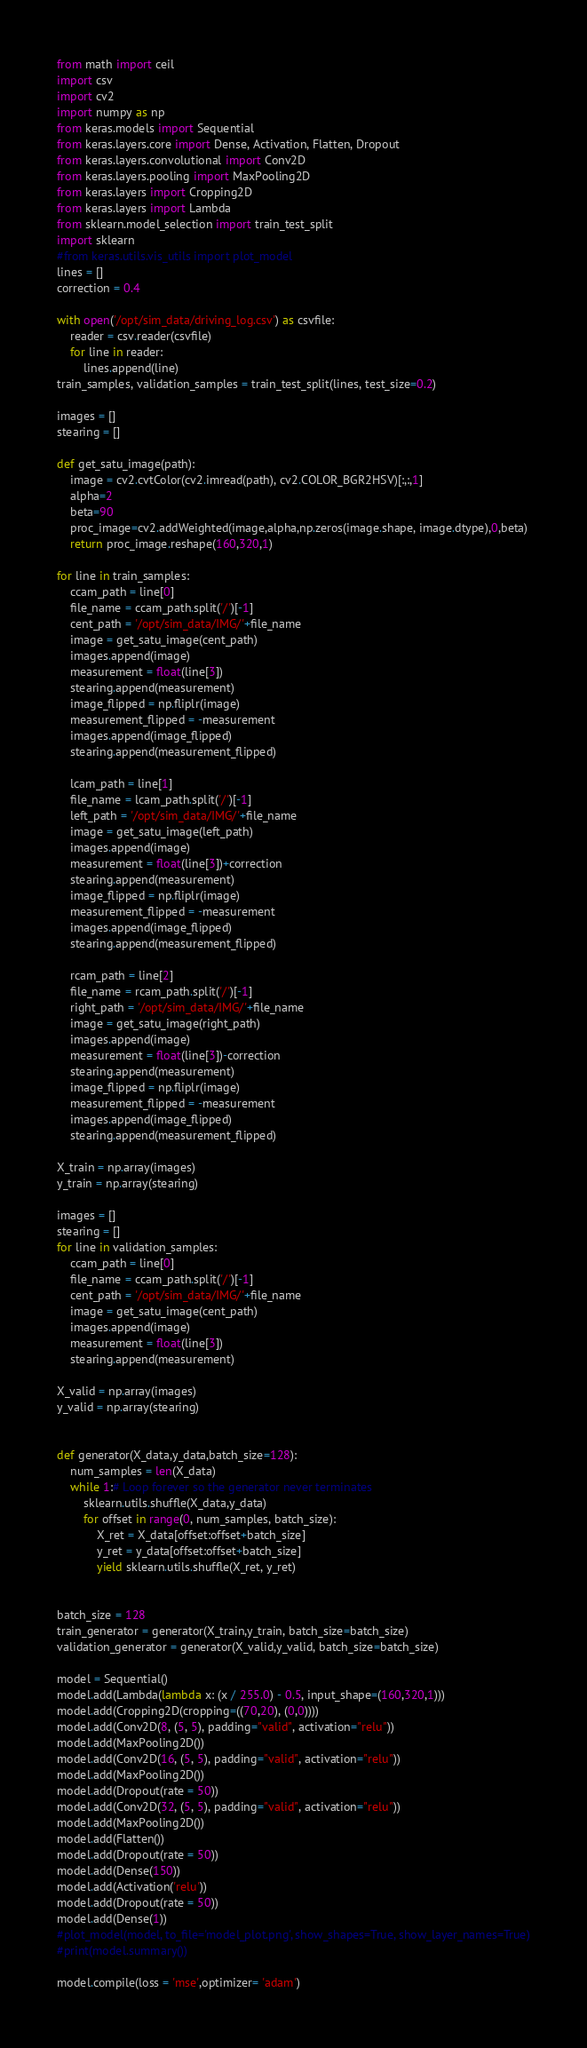Convert code to text. <code><loc_0><loc_0><loc_500><loc_500><_Python_>from math import ceil
import csv 
import cv2
import numpy as np
from keras.models import Sequential
from keras.layers.core import Dense, Activation, Flatten, Dropout
from keras.layers.convolutional import Conv2D
from keras.layers.pooling import MaxPooling2D
from keras.layers import Cropping2D
from keras.layers import Lambda
from sklearn.model_selection import train_test_split
import sklearn
#from keras.utils.vis_utils import plot_model
lines = []
correction = 0.4

with open('/opt/sim_data/driving_log.csv') as csvfile:
    reader = csv.reader(csvfile)
    for line in reader:
        lines.append(line)
train_samples, validation_samples = train_test_split(lines, test_size=0.2)

images = []
stearing = []

def get_satu_image(path):
    image = cv2.cvtColor(cv2.imread(path), cv2.COLOR_BGR2HSV)[:,:,1]
    alpha=2
    beta=90
    proc_image=cv2.addWeighted(image,alpha,np.zeros(image.shape, image.dtype),0,beta)
    return proc_image.reshape(160,320,1)
    
for line in train_samples:
    ccam_path = line[0]
    file_name = ccam_path.split('/')[-1]
    cent_path = '/opt/sim_data/IMG/'+file_name
    image = get_satu_image(cent_path)    
    images.append(image)
    measurement = float(line[3])
    stearing.append(measurement)
    image_flipped = np.fliplr(image)
    measurement_flipped = -measurement
    images.append(image_flipped)
    stearing.append(measurement_flipped)

    lcam_path = line[1]
    file_name = lcam_path.split('/')[-1]
    left_path = '/opt/sim_data/IMG/'+file_name
    image = get_satu_image(left_path)
    images.append(image)
    measurement = float(line[3])+correction
    stearing.append(measurement)
    image_flipped = np.fliplr(image)
    measurement_flipped = -measurement
    images.append(image_flipped)
    stearing.append(measurement_flipped)

    rcam_path = line[2]
    file_name = rcam_path.split('/')[-1]
    right_path = '/opt/sim_data/IMG/'+file_name
    image = get_satu_image(right_path)
    images.append(image)
    measurement = float(line[3])-correction
    stearing.append(measurement)
    image_flipped = np.fliplr(image)
    measurement_flipped = -measurement
    images.append(image_flipped)
    stearing.append(measurement_flipped)

X_train = np.array(images)
y_train = np.array(stearing)

images = []
stearing = []
for line in validation_samples:
    ccam_path = line[0]
    file_name = ccam_path.split('/')[-1]
    cent_path = '/opt/sim_data/IMG/'+file_name
    image = get_satu_image(cent_path)
    images.append(image)
    measurement = float(line[3])
    stearing.append(measurement)   

X_valid = np.array(images)
y_valid = np.array(stearing)


def generator(X_data,y_data,batch_size=128):
    num_samples = len(X_data)
    while 1:# Loop forever so the generator never terminates
        sklearn.utils.shuffle(X_data,y_data)
        for offset in range(0, num_samples, batch_size):
            X_ret = X_data[offset:offset+batch_size]
            y_ret = y_data[offset:offset+batch_size]
            yield sklearn.utils.shuffle(X_ret, y_ret)
            

batch_size = 128
train_generator = generator(X_train,y_train, batch_size=batch_size)
validation_generator = generator(X_valid,y_valid, batch_size=batch_size)

model = Sequential()
model.add(Lambda(lambda x: (x / 255.0) - 0.5, input_shape=(160,320,1)))
model.add(Cropping2D(cropping=((70,20), (0,0))))
model.add(Conv2D(8, (5, 5), padding="valid", activation="relu"))
model.add(MaxPooling2D())
model.add(Conv2D(16, (5, 5), padding="valid", activation="relu"))
model.add(MaxPooling2D())
model.add(Dropout(rate = 50))
model.add(Conv2D(32, (5, 5), padding="valid", activation="relu"))
model.add(MaxPooling2D())
model.add(Flatten())
model.add(Dropout(rate = 50))
model.add(Dense(150))
model.add(Activation('relu'))
model.add(Dropout(rate = 50))
model.add(Dense(1))
#plot_model(model, to_file='model_plot.png', show_shapes=True, show_layer_names=True)
#print(model.summary())

model.compile(loss = 'mse',optimizer= 'adam')</code> 